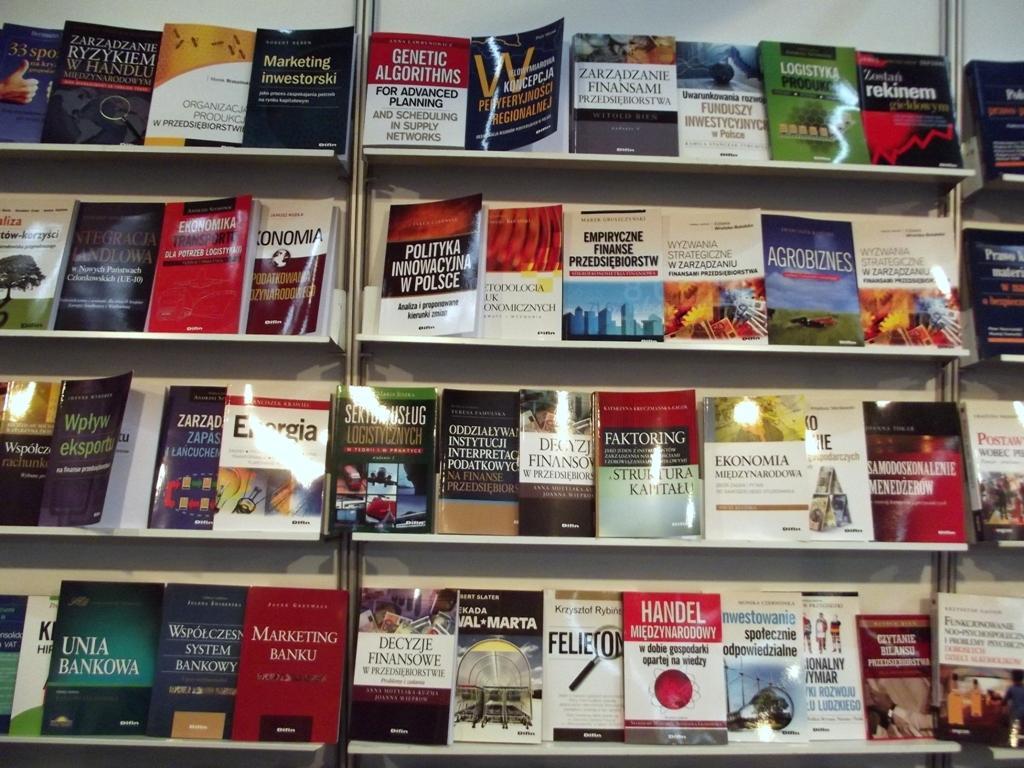Could you give a brief overview of what you see in this image? In the image there are cupboard with racks. On the racks there are many books. On the books there is something written on it. 